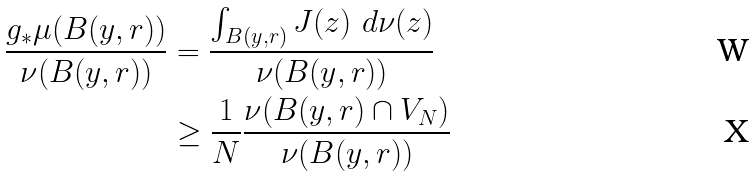Convert formula to latex. <formula><loc_0><loc_0><loc_500><loc_500>\frac { g _ { * } \mu ( B ( y , r ) ) } { \nu ( B ( y , r ) ) } & = \frac { \int _ { B ( y , r ) } J ( z ) \ d \nu ( z ) } { \nu ( B ( y , r ) ) } \\ & \geq \frac { 1 } { N } \frac { \nu ( B ( y , r ) \cap V _ { N } ) } { \nu ( B ( y , r ) ) }</formula> 